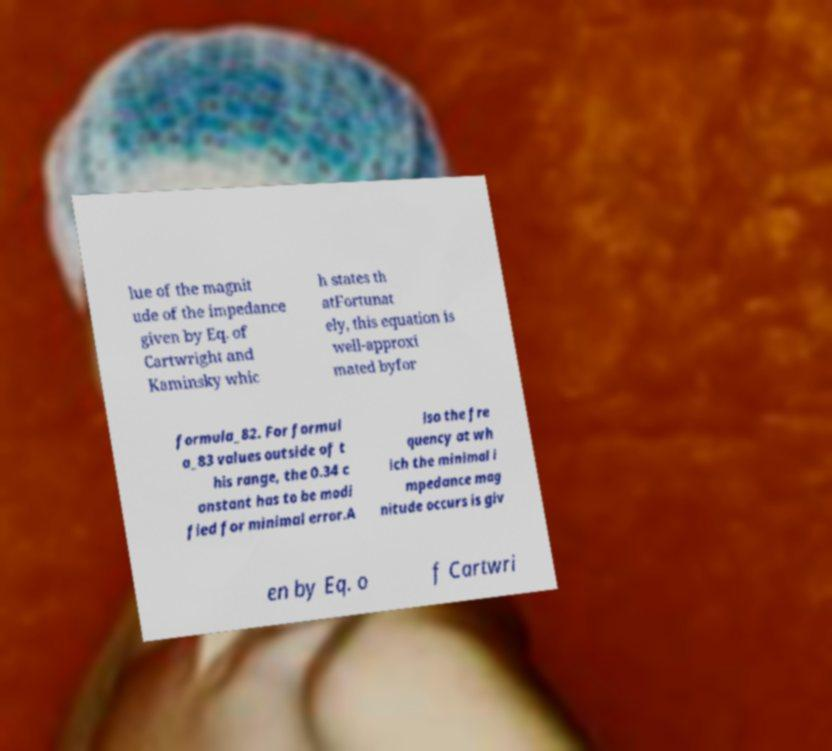For documentation purposes, I need the text within this image transcribed. Could you provide that? lue of the magnit ude of the impedance given by Eq. of Cartwright and Kaminsky whic h states th atFortunat ely, this equation is well-approxi mated byfor formula_82. For formul a_83 values outside of t his range, the 0.34 c onstant has to be modi fied for minimal error.A lso the fre quency at wh ich the minimal i mpedance mag nitude occurs is giv en by Eq. o f Cartwri 